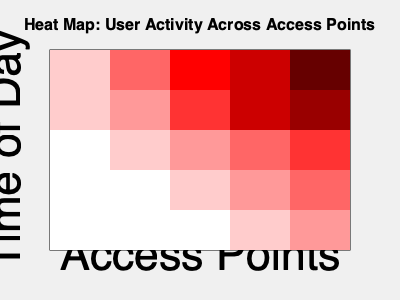Based on the heat map of user activity across different access points, which access point experiences the highest user activity during the earliest part of the day? To determine which access point experiences the highest user activity during the earliest part of the day, we need to follow these steps:

1. Identify the earliest part of the day on the heat map:
   - The y-axis represents the time of day, with earlier times at the top.
   - The top row of the heat map corresponds to the earliest part of the day.

2. Analyze the color intensity in the top row:
   - Darker red colors indicate higher user activity.
   - Lighter colors (pink to white) indicate lower user activity.

3. Compare the color intensities across the top row:
   - From left to right, the colors are: light pink, medium red, dark red, medium-dark red, very dark red.
   - The darkest red in the top row is the third square from the left.

4. Correlate the position to the access point:
   - The x-axis represents different access points.
   - The third square from the left corresponds to the middle access point.

Therefore, the access point that experiences the highest user activity during the earliest part of the day is the middle access point, represented by the third column from the left in the heat map.
Answer: Middle access point 